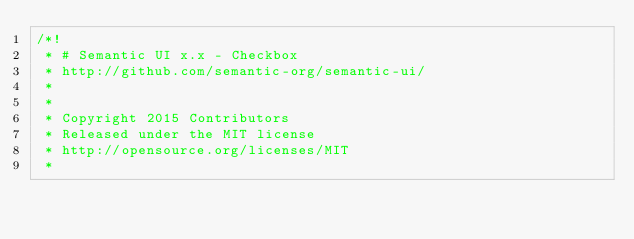<code> <loc_0><loc_0><loc_500><loc_500><_CSS_>/*!
 * # Semantic UI x.x - Checkbox
 * http://github.com/semantic-org/semantic-ui/
 *
 *
 * Copyright 2015 Contributors
 * Released under the MIT license
 * http://opensource.org/licenses/MIT
 *</code> 